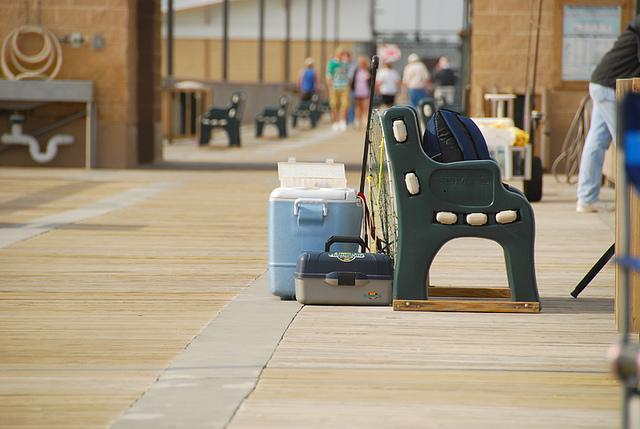What will the person who left this gear do with it?
Select the accurate response from the four choices given to answer the question.
Options: Catch butterflies, go fishing, have picnic, water ski. Go fishing. 